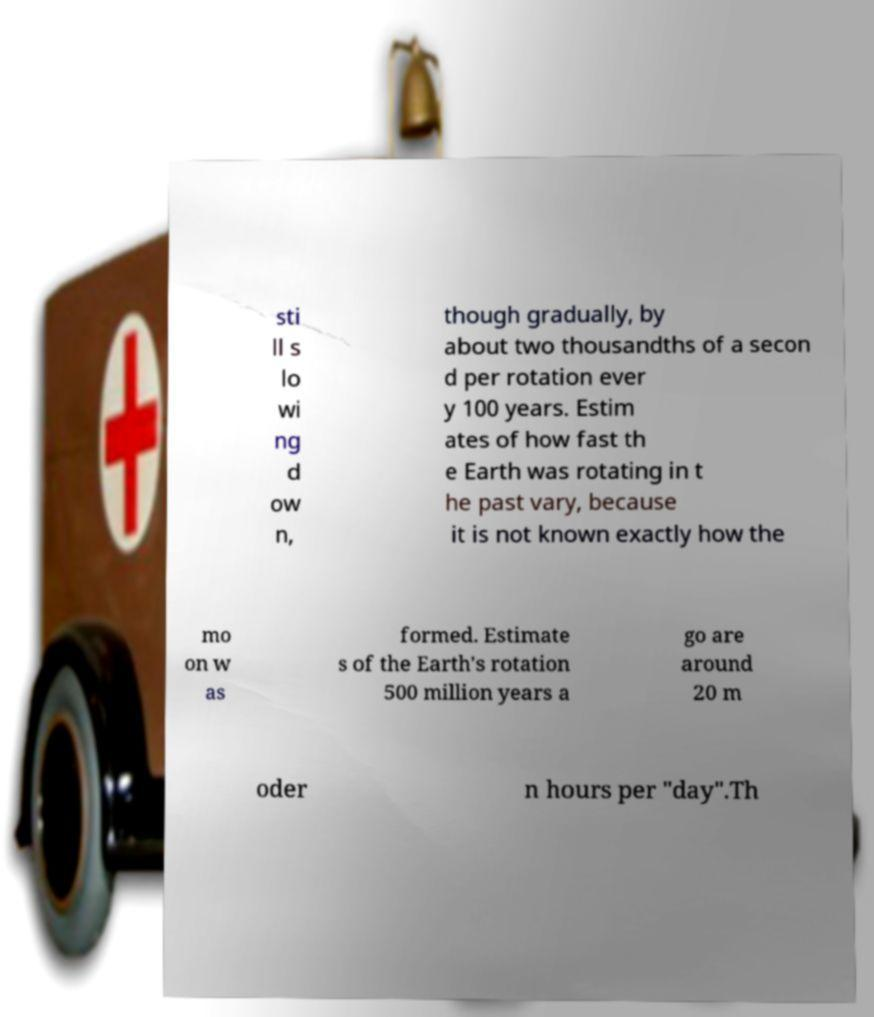Can you read and provide the text displayed in the image?This photo seems to have some interesting text. Can you extract and type it out for me? sti ll s lo wi ng d ow n, though gradually, by about two thousandths of a secon d per rotation ever y 100 years. Estim ates of how fast th e Earth was rotating in t he past vary, because it is not known exactly how the mo on w as formed. Estimate s of the Earth's rotation 500 million years a go are around 20 m oder n hours per "day".Th 